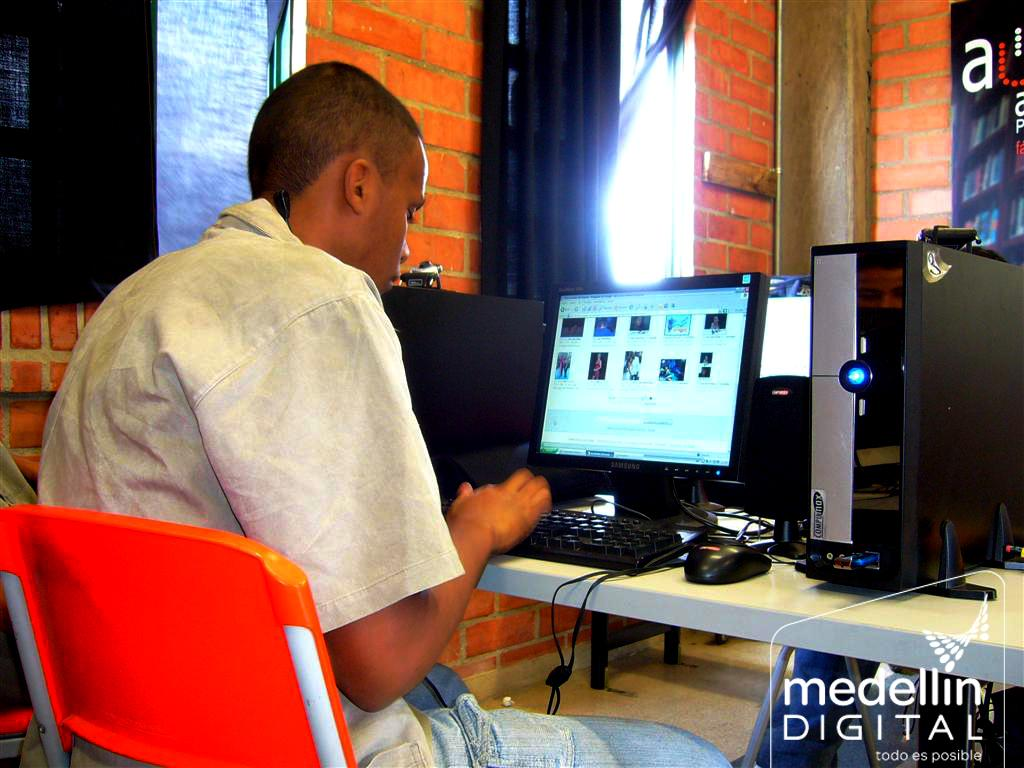<image>
Share a concise interpretation of the image provided. A man sitting at his computer is marked with a medellin digital watermark in the corner. 